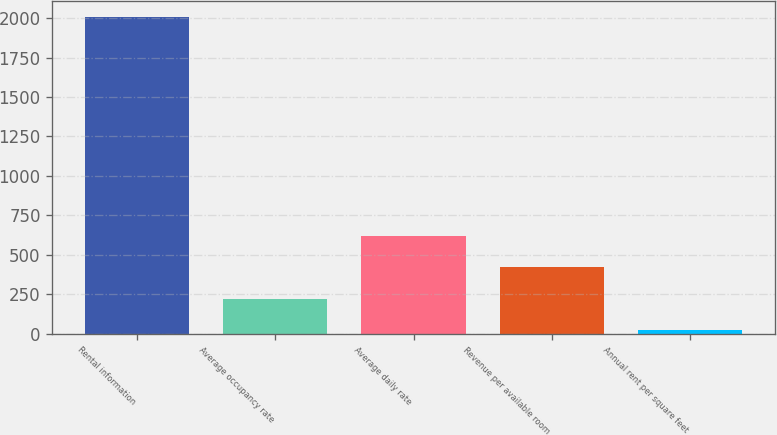Convert chart to OTSL. <chart><loc_0><loc_0><loc_500><loc_500><bar_chart><fcel>Rental information<fcel>Average occupancy rate<fcel>Average daily rate<fcel>Revenue per available room<fcel>Annual rent per square feet<nl><fcel>2007<fcel>220.71<fcel>617.67<fcel>419.19<fcel>22.23<nl></chart> 